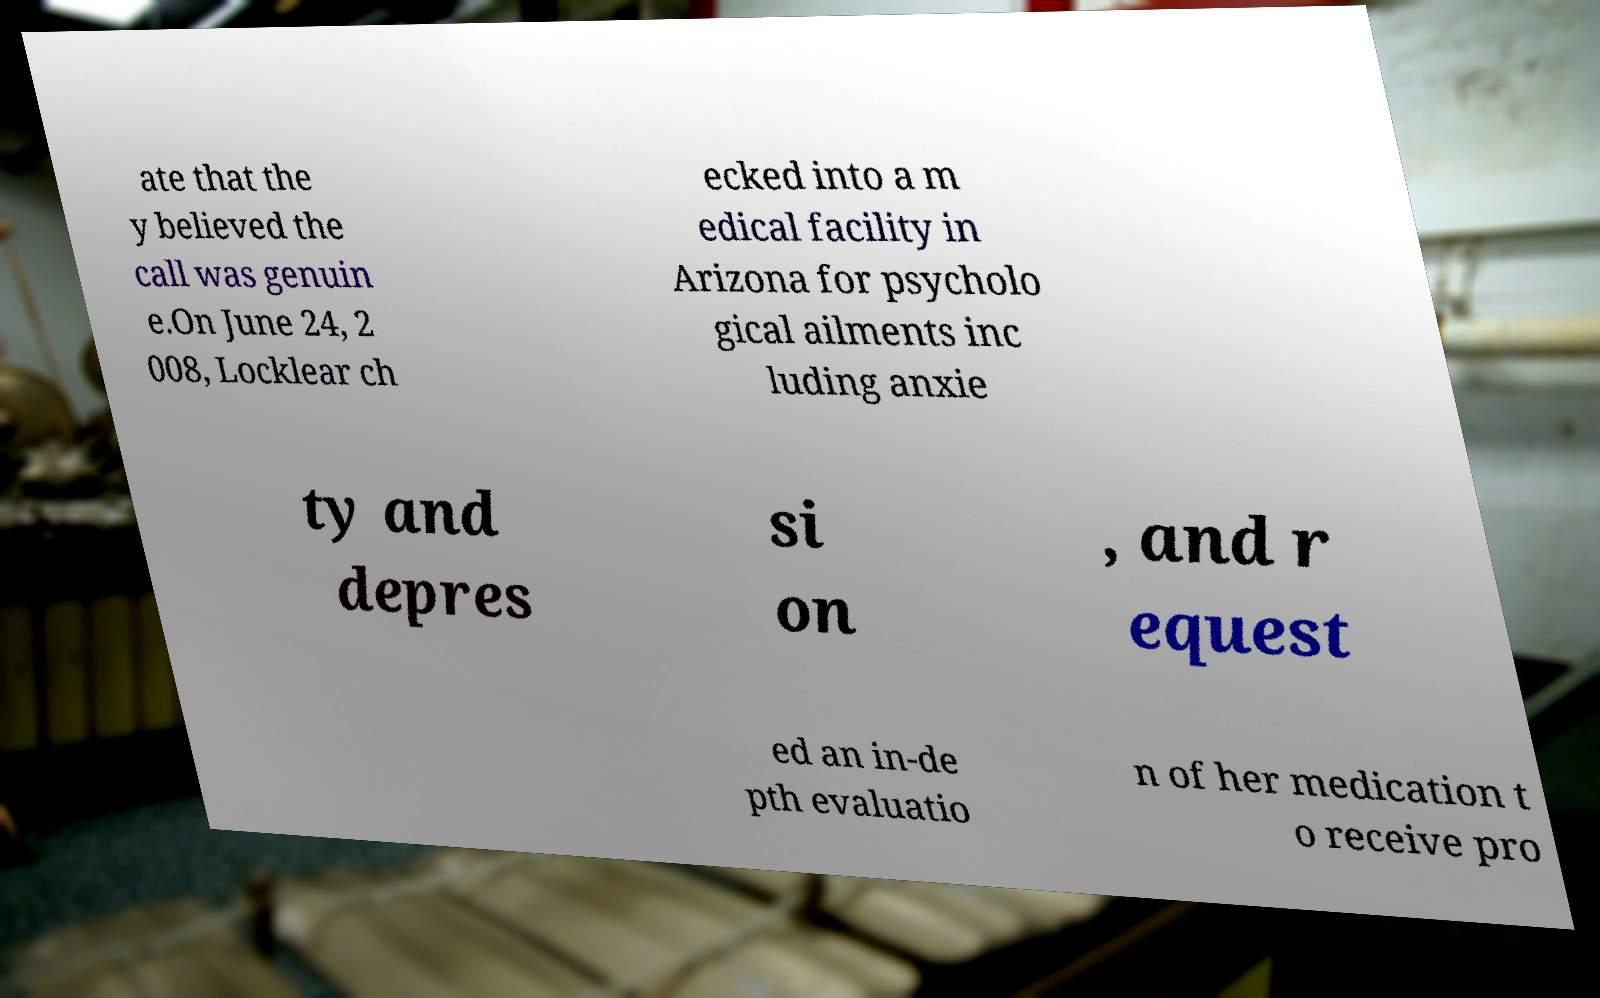For documentation purposes, I need the text within this image transcribed. Could you provide that? ate that the y believed the call was genuin e.On June 24, 2 008, Locklear ch ecked into a m edical facility in Arizona for psycholo gical ailments inc luding anxie ty and depres si on , and r equest ed an in-de pth evaluatio n of her medication t o receive pro 